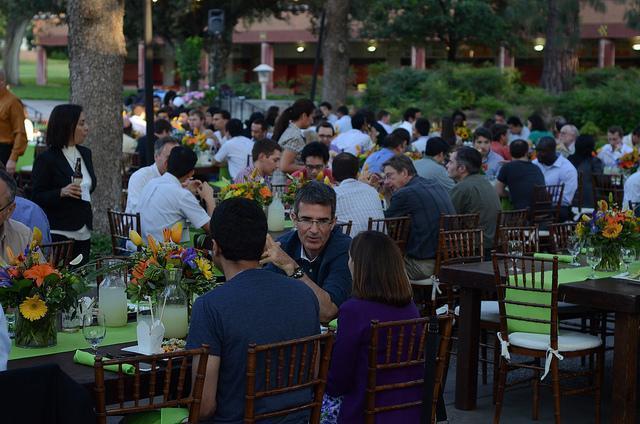What type of event is this?
Answer the question by selecting the correct answer among the 4 following choices and explain your choice with a short sentence. The answer should be formatted with the following format: `Answer: choice
Rationale: rationale.`
Options: Show, reception, presentation, meeting. Answer: reception.
Rationale: The people are sitting at banquet tables which are decorated with pretty green table runners, flowers in vases, and dinnerware.  some people are eating and there are pitchers of lemonade on the tables. 